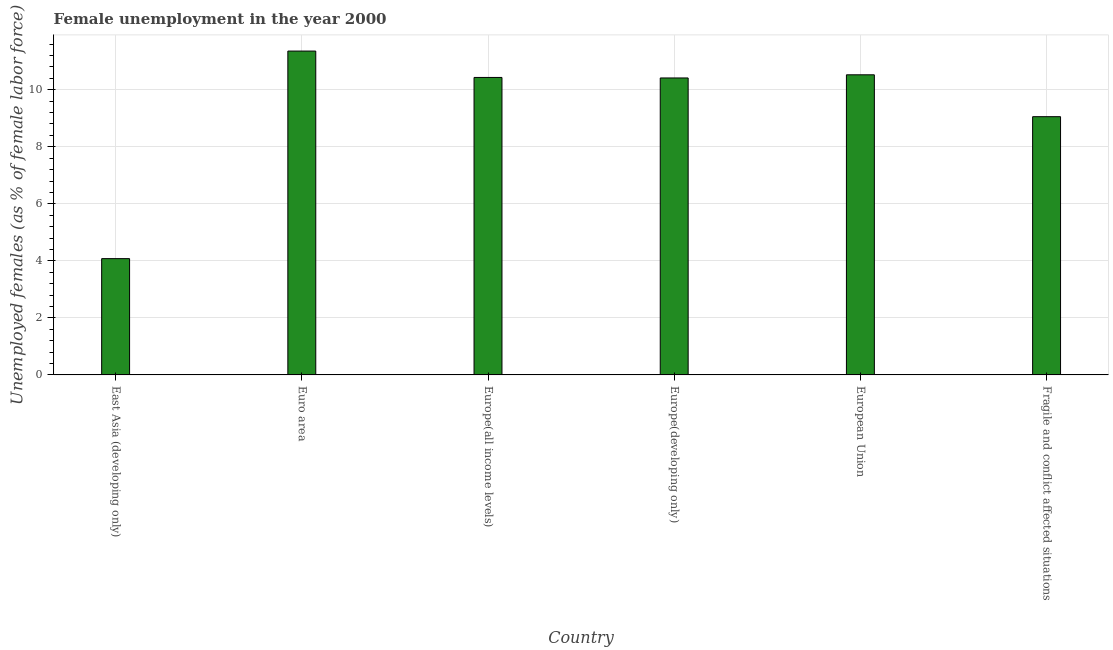Does the graph contain any zero values?
Your answer should be very brief. No. What is the title of the graph?
Provide a succinct answer. Female unemployment in the year 2000. What is the label or title of the X-axis?
Your answer should be compact. Country. What is the label or title of the Y-axis?
Make the answer very short. Unemployed females (as % of female labor force). What is the unemployed females population in Euro area?
Give a very brief answer. 11.36. Across all countries, what is the maximum unemployed females population?
Make the answer very short. 11.36. Across all countries, what is the minimum unemployed females population?
Offer a terse response. 4.08. In which country was the unemployed females population minimum?
Your answer should be very brief. East Asia (developing only). What is the sum of the unemployed females population?
Make the answer very short. 55.86. What is the difference between the unemployed females population in Europe(all income levels) and Fragile and conflict affected situations?
Your response must be concise. 1.38. What is the average unemployed females population per country?
Your response must be concise. 9.31. What is the median unemployed females population?
Provide a short and direct response. 10.42. What is the ratio of the unemployed females population in European Union to that in Fragile and conflict affected situations?
Offer a terse response. 1.16. What is the difference between the highest and the second highest unemployed females population?
Offer a very short reply. 0.83. What is the difference between the highest and the lowest unemployed females population?
Your answer should be very brief. 7.28. In how many countries, is the unemployed females population greater than the average unemployed females population taken over all countries?
Your response must be concise. 4. Are all the bars in the graph horizontal?
Your response must be concise. No. How many countries are there in the graph?
Keep it short and to the point. 6. What is the difference between two consecutive major ticks on the Y-axis?
Your answer should be very brief. 2. What is the Unemployed females (as % of female labor force) in East Asia (developing only)?
Offer a terse response. 4.08. What is the Unemployed females (as % of female labor force) of Euro area?
Offer a very short reply. 11.36. What is the Unemployed females (as % of female labor force) of Europe(all income levels)?
Provide a short and direct response. 10.43. What is the Unemployed females (as % of female labor force) in Europe(developing only)?
Provide a succinct answer. 10.41. What is the Unemployed females (as % of female labor force) in European Union?
Keep it short and to the point. 10.52. What is the Unemployed females (as % of female labor force) of Fragile and conflict affected situations?
Keep it short and to the point. 9.06. What is the difference between the Unemployed females (as % of female labor force) in East Asia (developing only) and Euro area?
Provide a succinct answer. -7.28. What is the difference between the Unemployed females (as % of female labor force) in East Asia (developing only) and Europe(all income levels)?
Keep it short and to the point. -6.35. What is the difference between the Unemployed females (as % of female labor force) in East Asia (developing only) and Europe(developing only)?
Provide a short and direct response. -6.34. What is the difference between the Unemployed females (as % of female labor force) in East Asia (developing only) and European Union?
Keep it short and to the point. -6.45. What is the difference between the Unemployed females (as % of female labor force) in East Asia (developing only) and Fragile and conflict affected situations?
Make the answer very short. -4.98. What is the difference between the Unemployed females (as % of female labor force) in Euro area and Europe(all income levels)?
Make the answer very short. 0.93. What is the difference between the Unemployed females (as % of female labor force) in Euro area and Europe(developing only)?
Offer a very short reply. 0.94. What is the difference between the Unemployed females (as % of female labor force) in Euro area and European Union?
Your response must be concise. 0.83. What is the difference between the Unemployed females (as % of female labor force) in Euro area and Fragile and conflict affected situations?
Your response must be concise. 2.3. What is the difference between the Unemployed females (as % of female labor force) in Europe(all income levels) and Europe(developing only)?
Make the answer very short. 0.02. What is the difference between the Unemployed females (as % of female labor force) in Europe(all income levels) and European Union?
Your answer should be very brief. -0.09. What is the difference between the Unemployed females (as % of female labor force) in Europe(all income levels) and Fragile and conflict affected situations?
Offer a terse response. 1.38. What is the difference between the Unemployed females (as % of female labor force) in Europe(developing only) and European Union?
Keep it short and to the point. -0.11. What is the difference between the Unemployed females (as % of female labor force) in Europe(developing only) and Fragile and conflict affected situations?
Make the answer very short. 1.36. What is the difference between the Unemployed females (as % of female labor force) in European Union and Fragile and conflict affected situations?
Make the answer very short. 1.47. What is the ratio of the Unemployed females (as % of female labor force) in East Asia (developing only) to that in Euro area?
Give a very brief answer. 0.36. What is the ratio of the Unemployed females (as % of female labor force) in East Asia (developing only) to that in Europe(all income levels)?
Your response must be concise. 0.39. What is the ratio of the Unemployed females (as % of female labor force) in East Asia (developing only) to that in Europe(developing only)?
Provide a short and direct response. 0.39. What is the ratio of the Unemployed females (as % of female labor force) in East Asia (developing only) to that in European Union?
Offer a terse response. 0.39. What is the ratio of the Unemployed females (as % of female labor force) in East Asia (developing only) to that in Fragile and conflict affected situations?
Provide a short and direct response. 0.45. What is the ratio of the Unemployed females (as % of female labor force) in Euro area to that in Europe(all income levels)?
Provide a short and direct response. 1.09. What is the ratio of the Unemployed females (as % of female labor force) in Euro area to that in Europe(developing only)?
Your response must be concise. 1.09. What is the ratio of the Unemployed females (as % of female labor force) in Euro area to that in European Union?
Your answer should be compact. 1.08. What is the ratio of the Unemployed females (as % of female labor force) in Euro area to that in Fragile and conflict affected situations?
Your answer should be very brief. 1.25. What is the ratio of the Unemployed females (as % of female labor force) in Europe(all income levels) to that in Fragile and conflict affected situations?
Your answer should be compact. 1.15. What is the ratio of the Unemployed females (as % of female labor force) in Europe(developing only) to that in Fragile and conflict affected situations?
Make the answer very short. 1.15. What is the ratio of the Unemployed females (as % of female labor force) in European Union to that in Fragile and conflict affected situations?
Your answer should be compact. 1.16. 